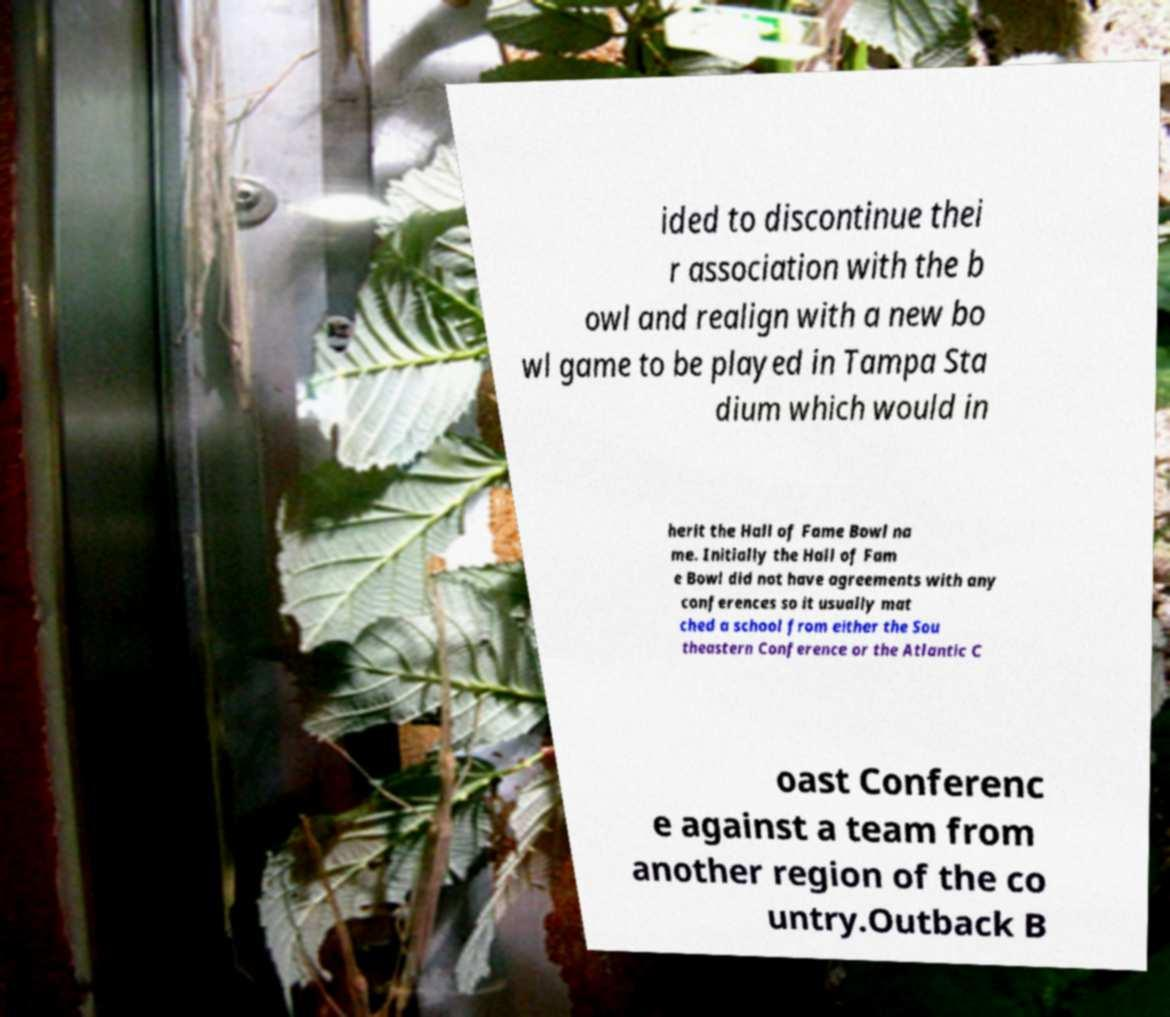Could you extract and type out the text from this image? ided to discontinue thei r association with the b owl and realign with a new bo wl game to be played in Tampa Sta dium which would in herit the Hall of Fame Bowl na me. Initially the Hall of Fam e Bowl did not have agreements with any conferences so it usually mat ched a school from either the Sou theastern Conference or the Atlantic C oast Conferenc e against a team from another region of the co untry.Outback B 